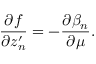Convert formula to latex. <formula><loc_0><loc_0><loc_500><loc_500>\frac { \partial f } { \partial z _ { n } ^ { \prime } } = - \frac { \partial \beta _ { n } } { \partial \mu } .</formula> 